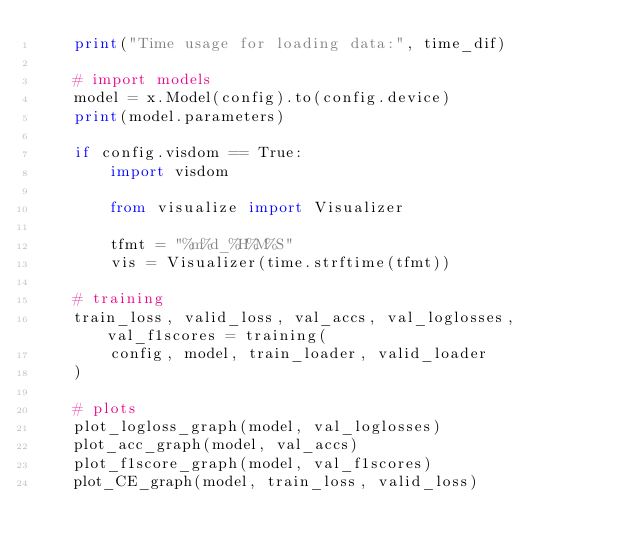<code> <loc_0><loc_0><loc_500><loc_500><_Python_>    print("Time usage for loading data:", time_dif)

    # import models
    model = x.Model(config).to(config.device)
    print(model.parameters)

    if config.visdom == True:
        import visdom

        from visualize import Visualizer

        tfmt = "%m%d_%H%M%S"
        vis = Visualizer(time.strftime(tfmt))

    # training
    train_loss, valid_loss, val_accs, val_loglosses, val_f1scores = training(
        config, model, train_loader, valid_loader
    )

    # plots
    plot_logloss_graph(model, val_loglosses)
    plot_acc_graph(model, val_accs)
    plot_f1score_graph(model, val_f1scores)
    plot_CE_graph(model, train_loss, valid_loss)
</code> 